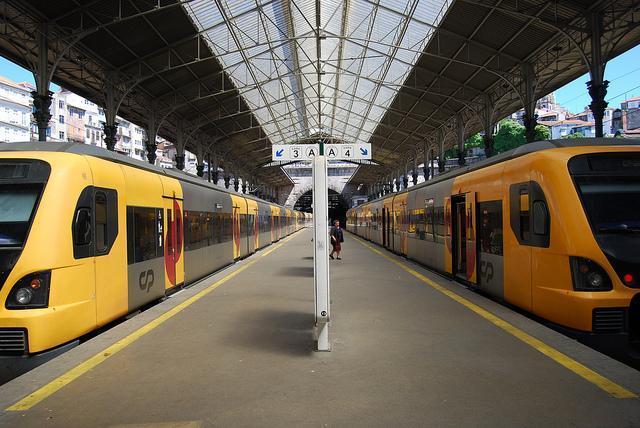How many trains are visible?
Give a very brief answer. 2. 